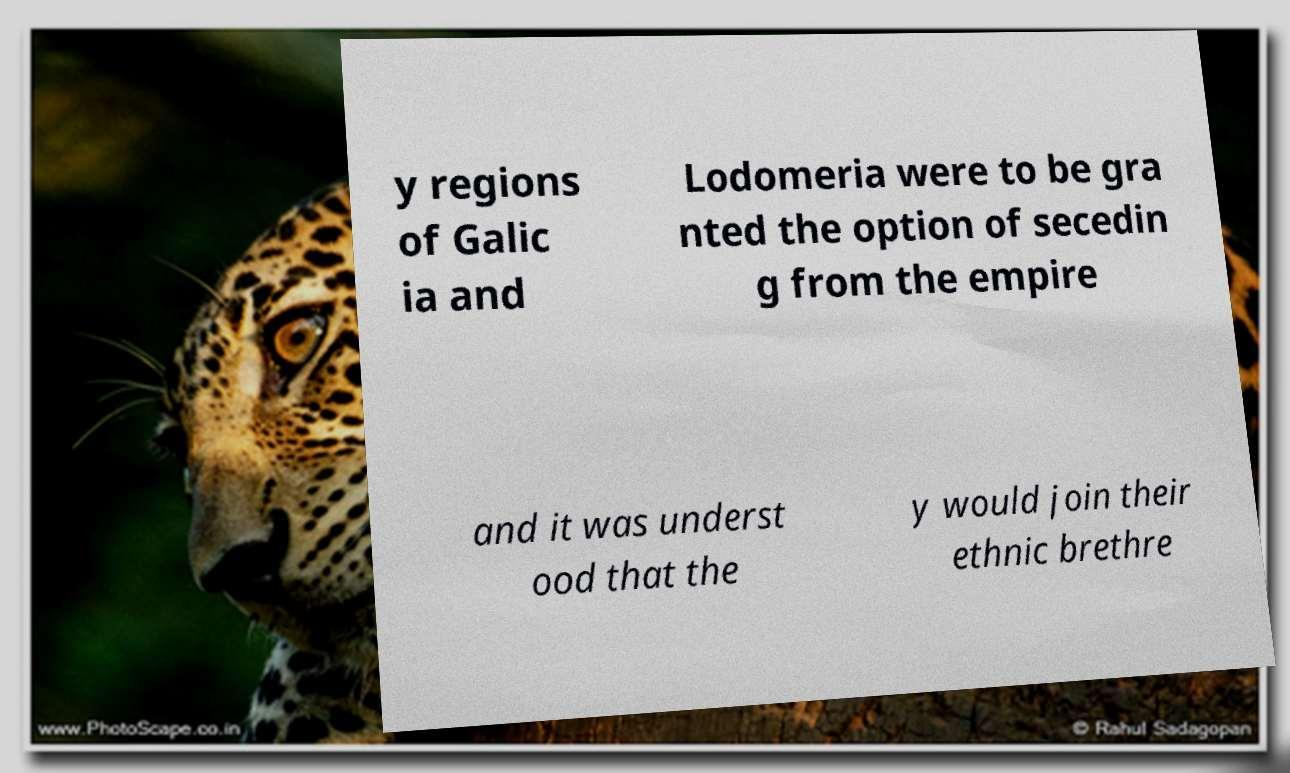Can you accurately transcribe the text from the provided image for me? y regions of Galic ia and Lodomeria were to be gra nted the option of secedin g from the empire and it was underst ood that the y would join their ethnic brethre 